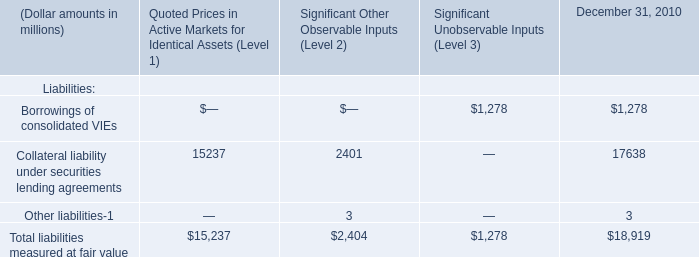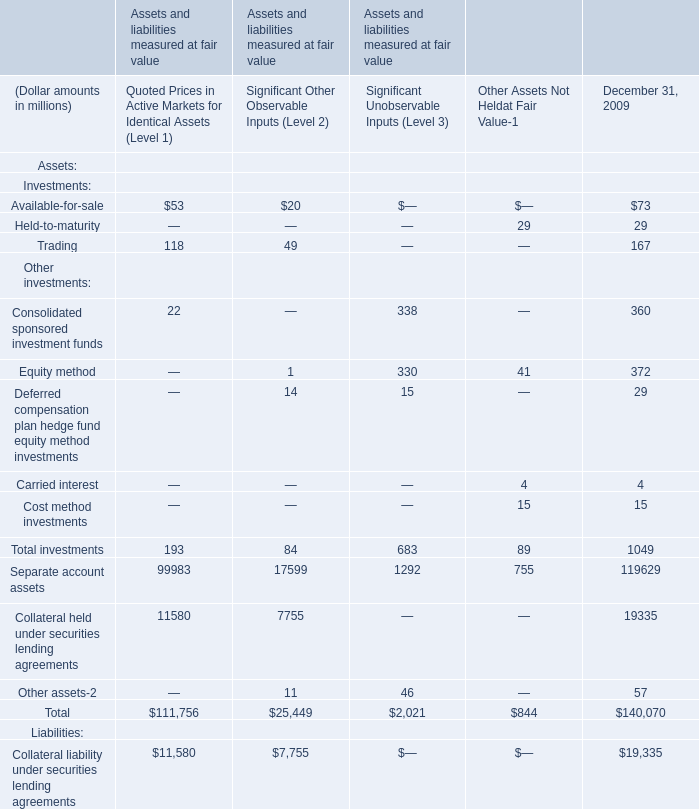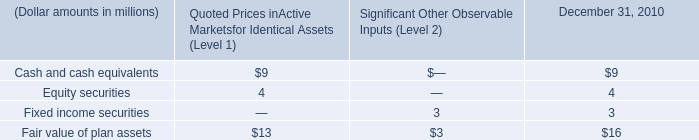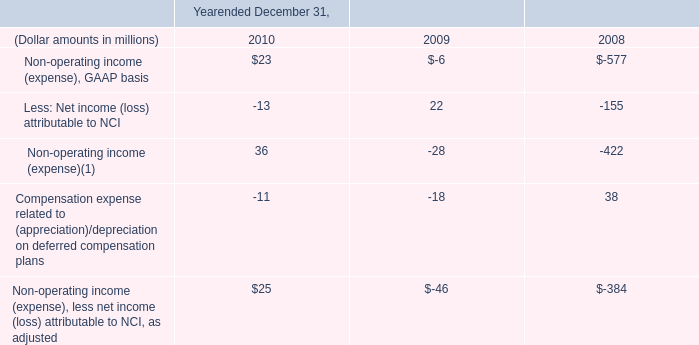what is the percentage change in expenses related to personal pension plan from 2008 to 2009? 
Computations: ((13 - 16) / 16)
Answer: -0.1875. 